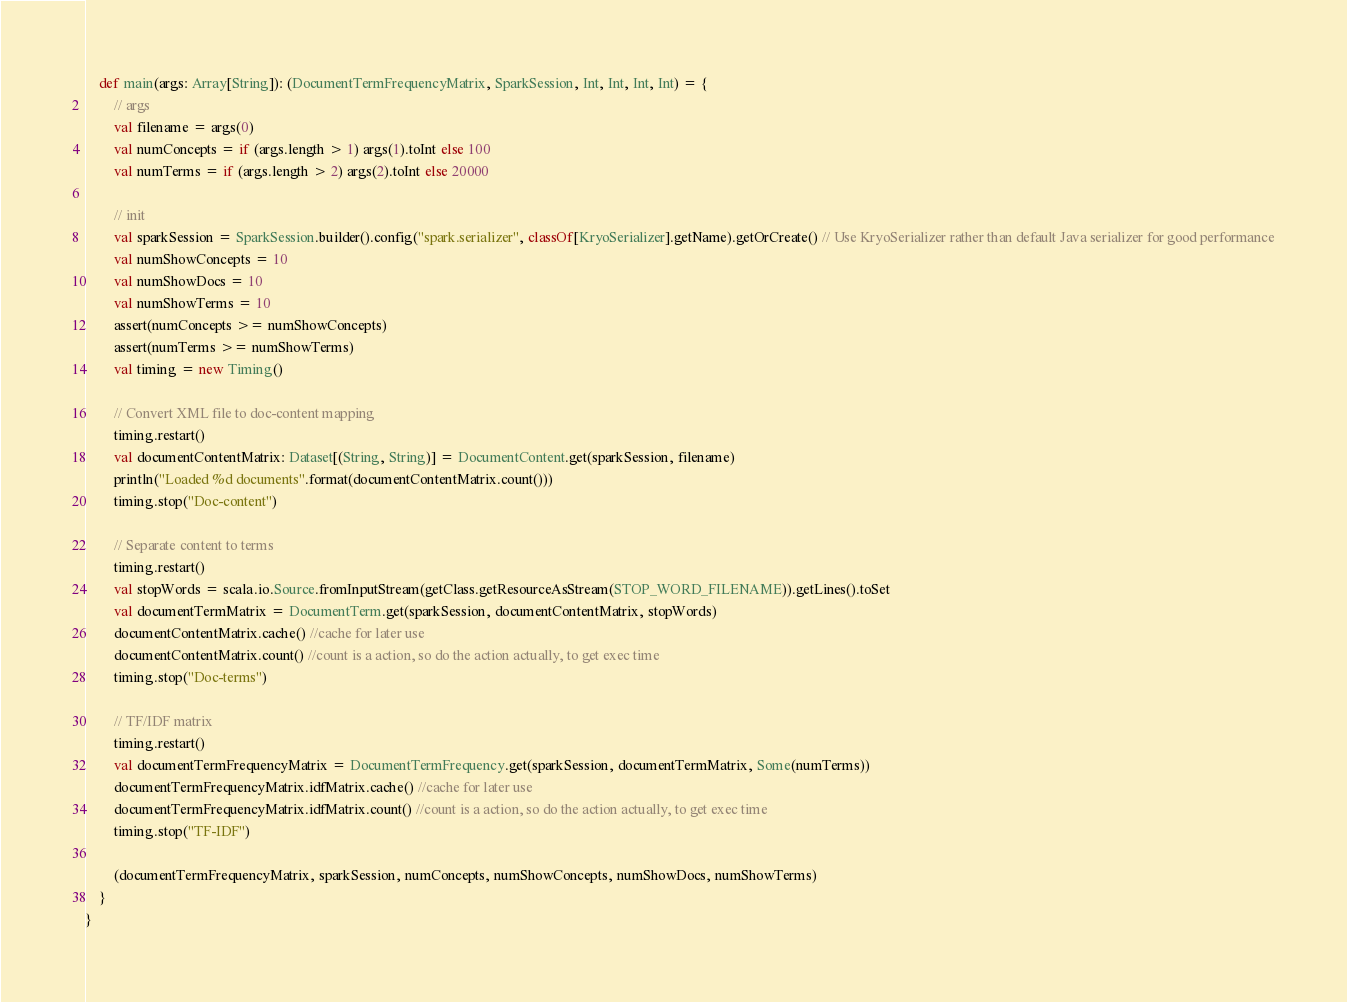Convert code to text. <code><loc_0><loc_0><loc_500><loc_500><_Scala_>
	def main(args: Array[String]): (DocumentTermFrequencyMatrix, SparkSession, Int, Int, Int, Int) = {
		// args
		val filename = args(0)
		val numConcepts = if (args.length > 1) args(1).toInt else 100
		val numTerms = if (args.length > 2) args(2).toInt else 20000

		// init
		val sparkSession = SparkSession.builder().config("spark.serializer", classOf[KryoSerializer].getName).getOrCreate() // Use KryoSerializer rather than default Java serializer for good performance
		val numShowConcepts = 10
		val numShowDocs = 10
		val numShowTerms = 10
		assert(numConcepts >= numShowConcepts)
		assert(numTerms >= numShowTerms)
		val timing = new Timing()

		// Convert XML file to doc-content mapping
		timing.restart()
		val documentContentMatrix: Dataset[(String, String)] = DocumentContent.get(sparkSession, filename)
		println("Loaded %d documents".format(documentContentMatrix.count()))
		timing.stop("Doc-content")

		// Separate content to terms
		timing.restart()
		val stopWords = scala.io.Source.fromInputStream(getClass.getResourceAsStream(STOP_WORD_FILENAME)).getLines().toSet
		val documentTermMatrix = DocumentTerm.get(sparkSession, documentContentMatrix, stopWords)
		documentContentMatrix.cache() //cache for later use
		documentContentMatrix.count() //count is a action, so do the action actually, to get exec time
		timing.stop("Doc-terms")

		// TF/IDF matrix
		timing.restart()
		val documentTermFrequencyMatrix = DocumentTermFrequency.get(sparkSession, documentTermMatrix, Some(numTerms))
		documentTermFrequencyMatrix.idfMatrix.cache() //cache for later use
		documentTermFrequencyMatrix.idfMatrix.count() //count is a action, so do the action actually, to get exec time
		timing.stop("TF-IDF")

		(documentTermFrequencyMatrix, sparkSession, numConcepts, numShowConcepts, numShowDocs, numShowTerms)
	}
}
</code> 